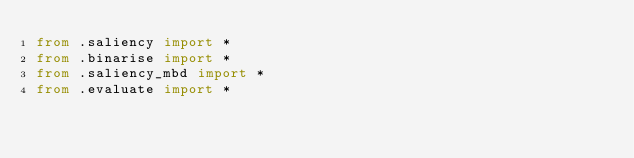Convert code to text. <code><loc_0><loc_0><loc_500><loc_500><_Python_>from .saliency import *
from .binarise import *
from .saliency_mbd import *
from .evaluate import *
</code> 